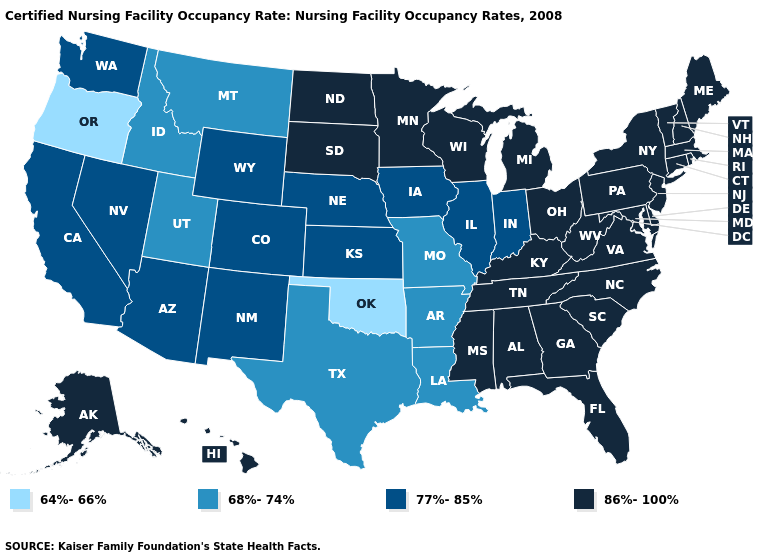What is the lowest value in states that border Virginia?
Keep it brief. 86%-100%. How many symbols are there in the legend?
Keep it brief. 4. What is the lowest value in states that border New Jersey?
Give a very brief answer. 86%-100%. Is the legend a continuous bar?
Give a very brief answer. No. What is the highest value in the West ?
Give a very brief answer. 86%-100%. What is the highest value in the MidWest ?
Answer briefly. 86%-100%. What is the highest value in states that border Massachusetts?
Write a very short answer. 86%-100%. Is the legend a continuous bar?
Answer briefly. No. What is the value of Connecticut?
Answer briefly. 86%-100%. Name the states that have a value in the range 64%-66%?
Give a very brief answer. Oklahoma, Oregon. What is the value of New Mexico?
Be succinct. 77%-85%. Among the states that border Montana , which have the highest value?
Give a very brief answer. North Dakota, South Dakota. Does Tennessee have a lower value than Oregon?
Short answer required. No. What is the value of Virginia?
Short answer required. 86%-100%. 